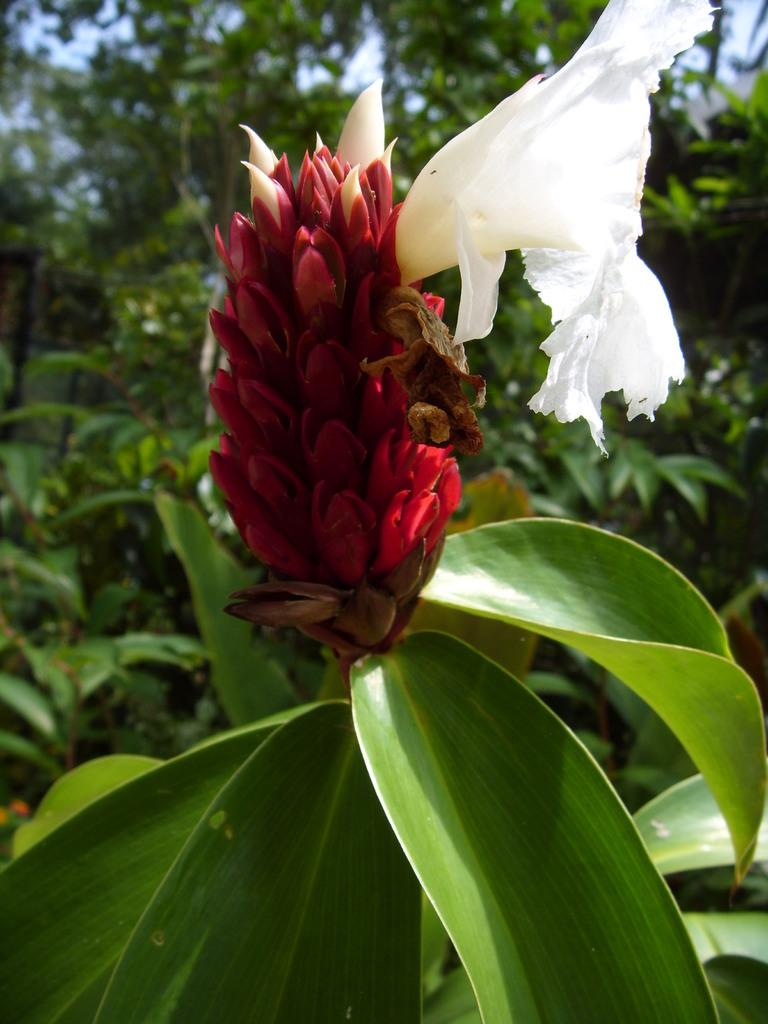What is the main subject in the front of the image? There is a flower in the front of the image. What else can be seen in the image besides the flower? There are leaves in the image. What is visible in the background of the image? There are plants and trees in the background of the image. What book is the flower reading in the image? There is no book or reading activity present in the image; it features a flower and other plant elements. 